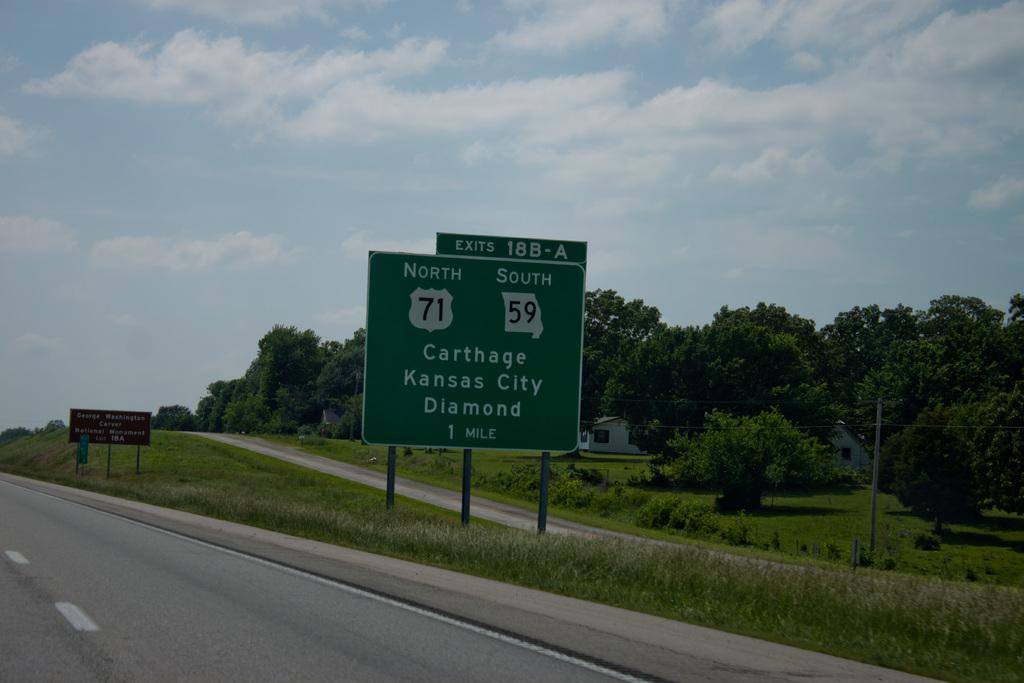What number is the exit?
Make the answer very short. 18b-a. How far away is the carthage exit?
Give a very brief answer. 1 mile. 